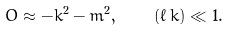<formula> <loc_0><loc_0><loc_500><loc_500>O \approx - k ^ { 2 } - m ^ { 2 } , \quad ( \ell \, k ) \ll 1 .</formula> 